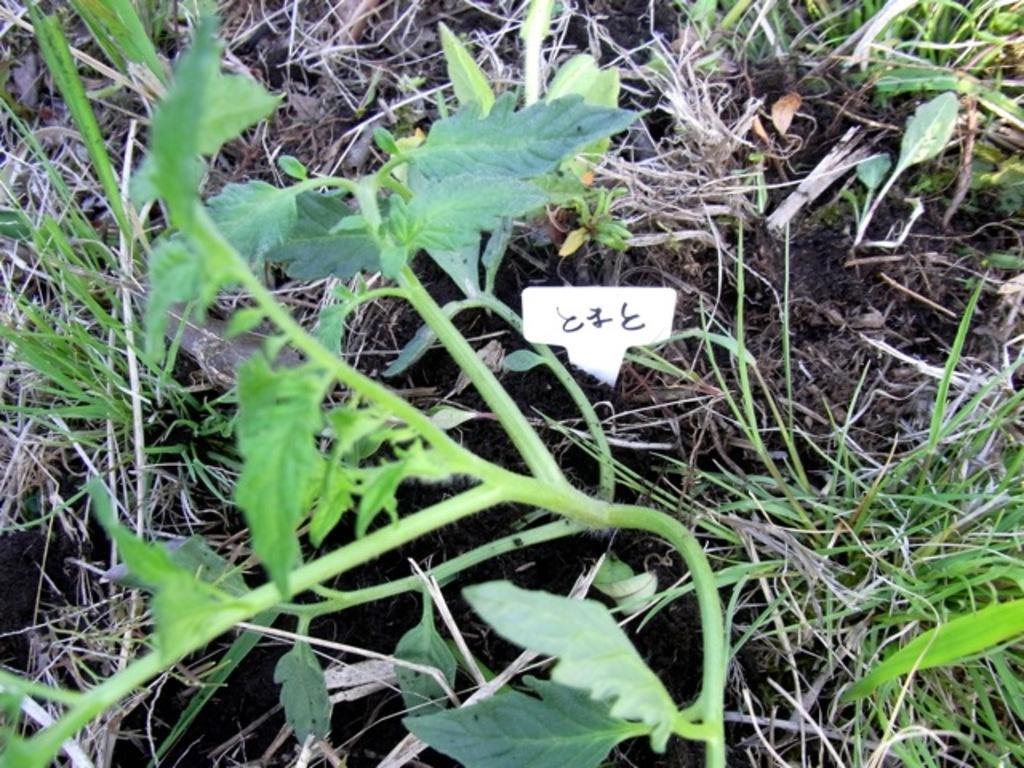What type of natural elements can be seen on the surface in the image? There are leaves, grass, and stems on the surface in the image. Can you describe the vegetation present on the surface in the image? The vegetation includes leaves, grass, and stems. What type of fuel is visible being used in the image? There is no fuel present in the image; it features leaves, grass, and stems on the surface. Can you tell me where the zoo is located in the image? There is no zoo present in the image; it features leaves, grass, and stems on the surface. 